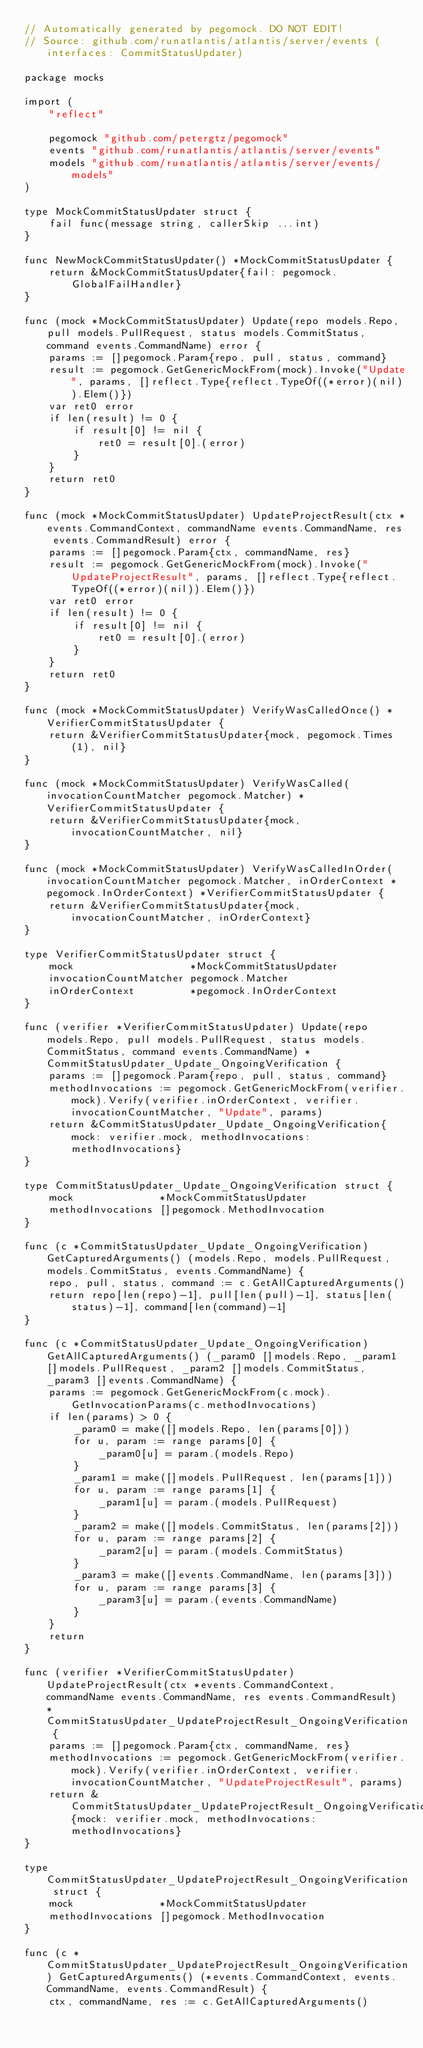Convert code to text. <code><loc_0><loc_0><loc_500><loc_500><_Go_>// Automatically generated by pegomock. DO NOT EDIT!
// Source: github.com/runatlantis/atlantis/server/events (interfaces: CommitStatusUpdater)

package mocks

import (
	"reflect"

	pegomock "github.com/petergtz/pegomock"
	events "github.com/runatlantis/atlantis/server/events"
	models "github.com/runatlantis/atlantis/server/events/models"
)

type MockCommitStatusUpdater struct {
	fail func(message string, callerSkip ...int)
}

func NewMockCommitStatusUpdater() *MockCommitStatusUpdater {
	return &MockCommitStatusUpdater{fail: pegomock.GlobalFailHandler}
}

func (mock *MockCommitStatusUpdater) Update(repo models.Repo, pull models.PullRequest, status models.CommitStatus, command events.CommandName) error {
	params := []pegomock.Param{repo, pull, status, command}
	result := pegomock.GetGenericMockFrom(mock).Invoke("Update", params, []reflect.Type{reflect.TypeOf((*error)(nil)).Elem()})
	var ret0 error
	if len(result) != 0 {
		if result[0] != nil {
			ret0 = result[0].(error)
		}
	}
	return ret0
}

func (mock *MockCommitStatusUpdater) UpdateProjectResult(ctx *events.CommandContext, commandName events.CommandName, res events.CommandResult) error {
	params := []pegomock.Param{ctx, commandName, res}
	result := pegomock.GetGenericMockFrom(mock).Invoke("UpdateProjectResult", params, []reflect.Type{reflect.TypeOf((*error)(nil)).Elem()})
	var ret0 error
	if len(result) != 0 {
		if result[0] != nil {
			ret0 = result[0].(error)
		}
	}
	return ret0
}

func (mock *MockCommitStatusUpdater) VerifyWasCalledOnce() *VerifierCommitStatusUpdater {
	return &VerifierCommitStatusUpdater{mock, pegomock.Times(1), nil}
}

func (mock *MockCommitStatusUpdater) VerifyWasCalled(invocationCountMatcher pegomock.Matcher) *VerifierCommitStatusUpdater {
	return &VerifierCommitStatusUpdater{mock, invocationCountMatcher, nil}
}

func (mock *MockCommitStatusUpdater) VerifyWasCalledInOrder(invocationCountMatcher pegomock.Matcher, inOrderContext *pegomock.InOrderContext) *VerifierCommitStatusUpdater {
	return &VerifierCommitStatusUpdater{mock, invocationCountMatcher, inOrderContext}
}

type VerifierCommitStatusUpdater struct {
	mock                   *MockCommitStatusUpdater
	invocationCountMatcher pegomock.Matcher
	inOrderContext         *pegomock.InOrderContext
}

func (verifier *VerifierCommitStatusUpdater) Update(repo models.Repo, pull models.PullRequest, status models.CommitStatus, command events.CommandName) *CommitStatusUpdater_Update_OngoingVerification {
	params := []pegomock.Param{repo, pull, status, command}
	methodInvocations := pegomock.GetGenericMockFrom(verifier.mock).Verify(verifier.inOrderContext, verifier.invocationCountMatcher, "Update", params)
	return &CommitStatusUpdater_Update_OngoingVerification{mock: verifier.mock, methodInvocations: methodInvocations}
}

type CommitStatusUpdater_Update_OngoingVerification struct {
	mock              *MockCommitStatusUpdater
	methodInvocations []pegomock.MethodInvocation
}

func (c *CommitStatusUpdater_Update_OngoingVerification) GetCapturedArguments() (models.Repo, models.PullRequest, models.CommitStatus, events.CommandName) {
	repo, pull, status, command := c.GetAllCapturedArguments()
	return repo[len(repo)-1], pull[len(pull)-1], status[len(status)-1], command[len(command)-1]
}

func (c *CommitStatusUpdater_Update_OngoingVerification) GetAllCapturedArguments() (_param0 []models.Repo, _param1 []models.PullRequest, _param2 []models.CommitStatus, _param3 []events.CommandName) {
	params := pegomock.GetGenericMockFrom(c.mock).GetInvocationParams(c.methodInvocations)
	if len(params) > 0 {
		_param0 = make([]models.Repo, len(params[0]))
		for u, param := range params[0] {
			_param0[u] = param.(models.Repo)
		}
		_param1 = make([]models.PullRequest, len(params[1]))
		for u, param := range params[1] {
			_param1[u] = param.(models.PullRequest)
		}
		_param2 = make([]models.CommitStatus, len(params[2]))
		for u, param := range params[2] {
			_param2[u] = param.(models.CommitStatus)
		}
		_param3 = make([]events.CommandName, len(params[3]))
		for u, param := range params[3] {
			_param3[u] = param.(events.CommandName)
		}
	}
	return
}

func (verifier *VerifierCommitStatusUpdater) UpdateProjectResult(ctx *events.CommandContext, commandName events.CommandName, res events.CommandResult) *CommitStatusUpdater_UpdateProjectResult_OngoingVerification {
	params := []pegomock.Param{ctx, commandName, res}
	methodInvocations := pegomock.GetGenericMockFrom(verifier.mock).Verify(verifier.inOrderContext, verifier.invocationCountMatcher, "UpdateProjectResult", params)
	return &CommitStatusUpdater_UpdateProjectResult_OngoingVerification{mock: verifier.mock, methodInvocations: methodInvocations}
}

type CommitStatusUpdater_UpdateProjectResult_OngoingVerification struct {
	mock              *MockCommitStatusUpdater
	methodInvocations []pegomock.MethodInvocation
}

func (c *CommitStatusUpdater_UpdateProjectResult_OngoingVerification) GetCapturedArguments() (*events.CommandContext, events.CommandName, events.CommandResult) {
	ctx, commandName, res := c.GetAllCapturedArguments()</code> 